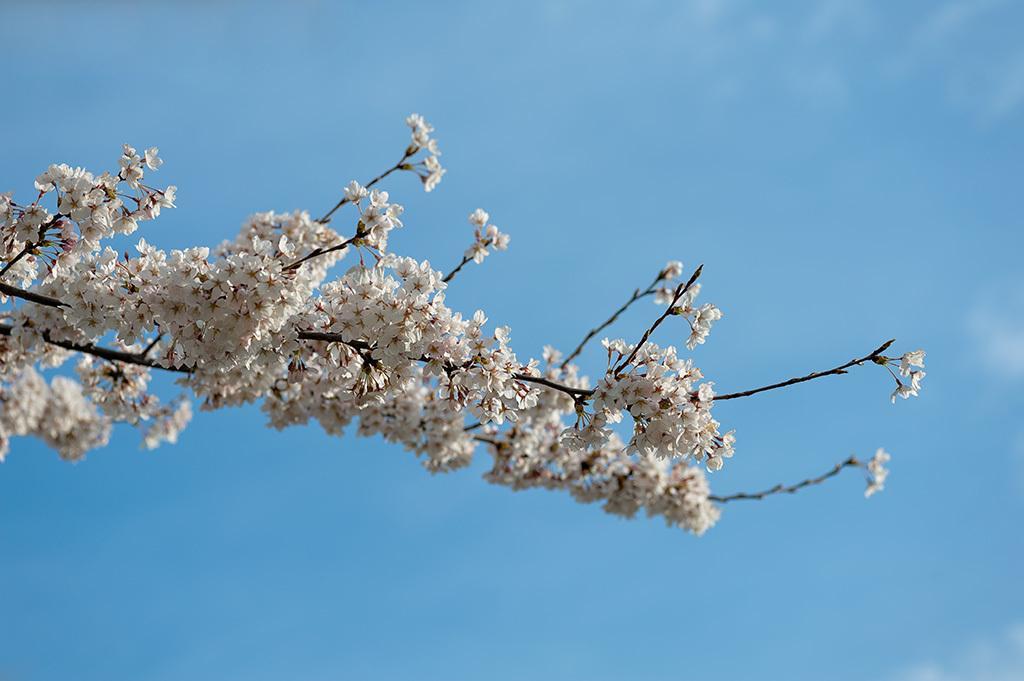Can you describe this image briefly? In this image, we can see bunch of flowers on the blue background. 